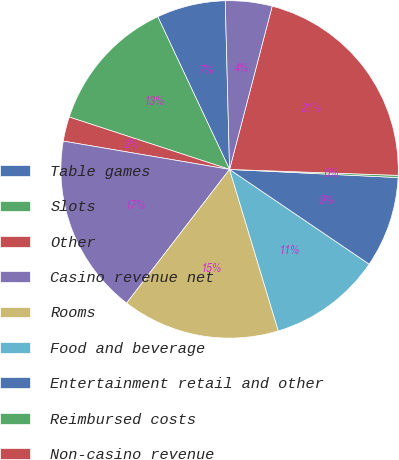<chart> <loc_0><loc_0><loc_500><loc_500><pie_chart><fcel>Table games<fcel>Slots<fcel>Other<fcel>Casino revenue net<fcel>Rooms<fcel>Food and beverage<fcel>Entertainment retail and other<fcel>Reimbursed costs<fcel>Non-casino revenue<fcel>Less Promotional allowances<nl><fcel>6.59%<fcel>12.98%<fcel>2.34%<fcel>17.24%<fcel>15.11%<fcel>10.85%<fcel>8.72%<fcel>0.21%<fcel>21.5%<fcel>4.47%<nl></chart> 